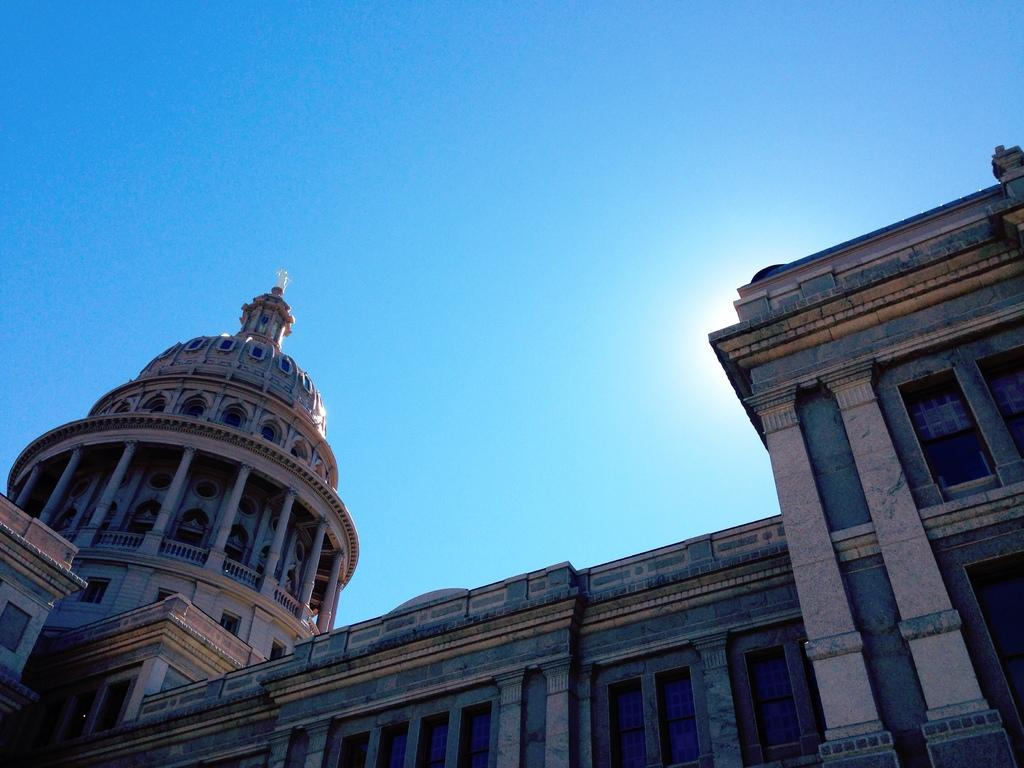What structure is the main subject of the image? There is a building in the image. What can be seen on the left side of the building? There is a flag on the top of the dome on the left side of the image. What is visible in the back of the image? The sun's light beam and the sky are visible in the back of the image. Can you tell me how many crackers are on the roof of the building in the image? There are no crackers present on the roof of the building in the image. What type of duck can be seen swimming in the sun's light beam? There are no ducks present in the image, and the sun's light beam is not a body of water where a duck could swim. 